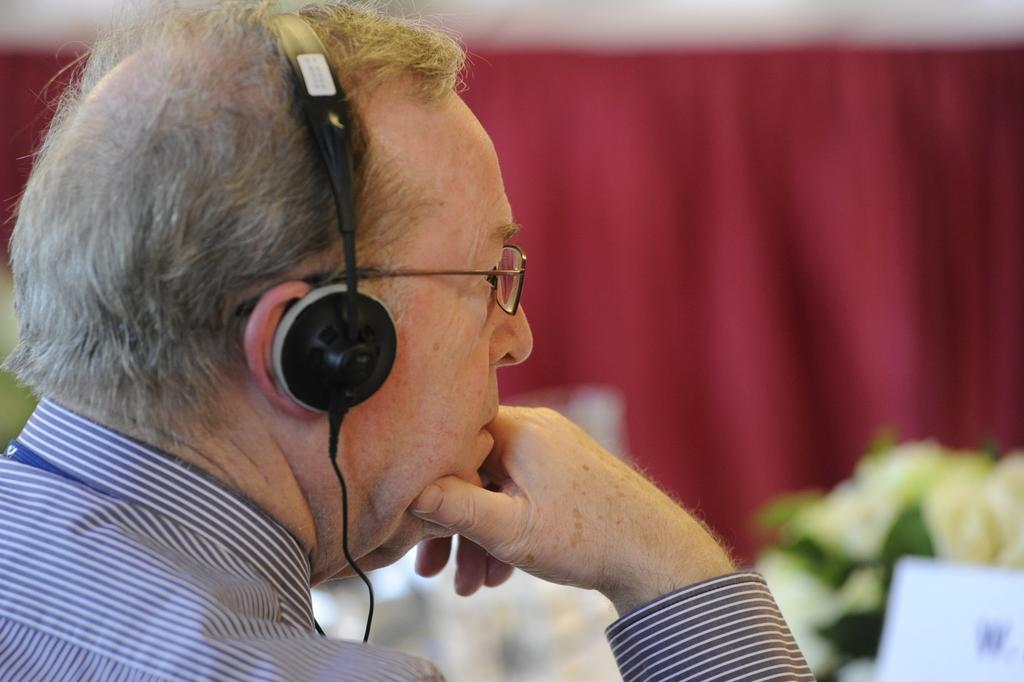What is the main subject of the image? There is a man in the image. What accessories is the man wearing? The man is wearing headphones and spectacles. What type of clothing is the man wearing? The man is wearing a shirt. What can be seen in the background of the image? There are red color curtains and other objects visible in the background of the image. Can you see a toad sitting on the man's headphones in the image? No, there is no toad present in the image. What type of coil is wrapped around the man's neck in the image? There is no coil visible in the image. 